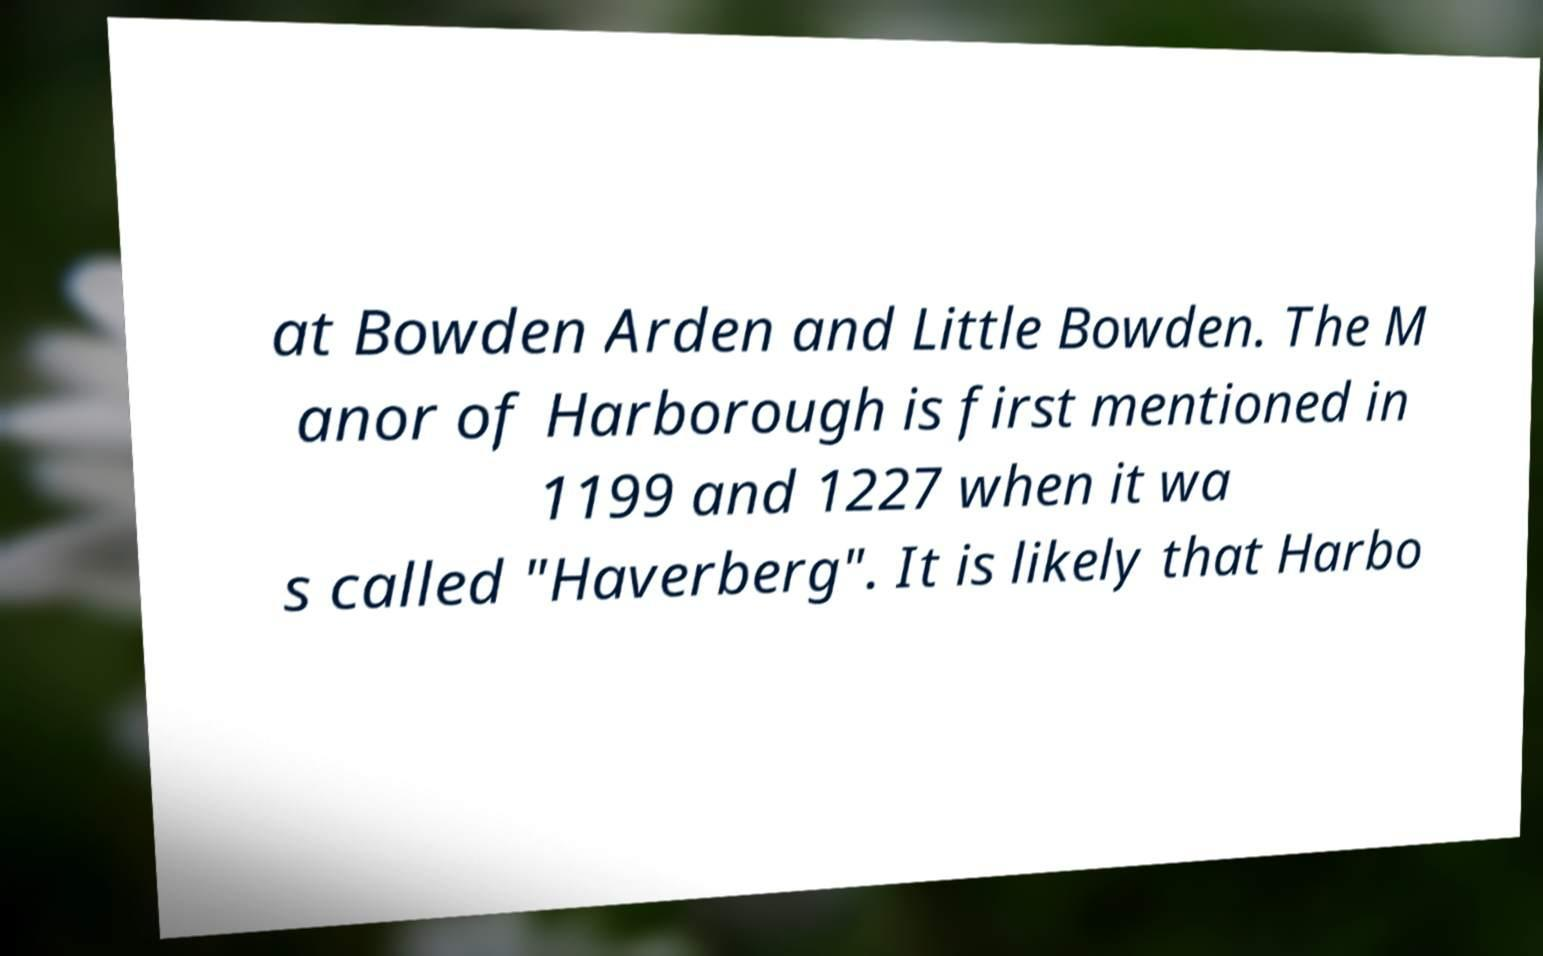Can you read and provide the text displayed in the image?This photo seems to have some interesting text. Can you extract and type it out for me? at Bowden Arden and Little Bowden. The M anor of Harborough is first mentioned in 1199 and 1227 when it wa s called "Haverberg". It is likely that Harbo 